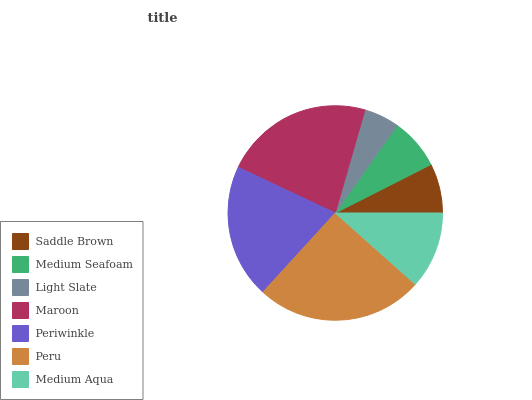Is Light Slate the minimum?
Answer yes or no. Yes. Is Peru the maximum?
Answer yes or no. Yes. Is Medium Seafoam the minimum?
Answer yes or no. No. Is Medium Seafoam the maximum?
Answer yes or no. No. Is Medium Seafoam greater than Saddle Brown?
Answer yes or no. Yes. Is Saddle Brown less than Medium Seafoam?
Answer yes or no. Yes. Is Saddle Brown greater than Medium Seafoam?
Answer yes or no. No. Is Medium Seafoam less than Saddle Brown?
Answer yes or no. No. Is Medium Aqua the high median?
Answer yes or no. Yes. Is Medium Aqua the low median?
Answer yes or no. Yes. Is Maroon the high median?
Answer yes or no. No. Is Medium Seafoam the low median?
Answer yes or no. No. 